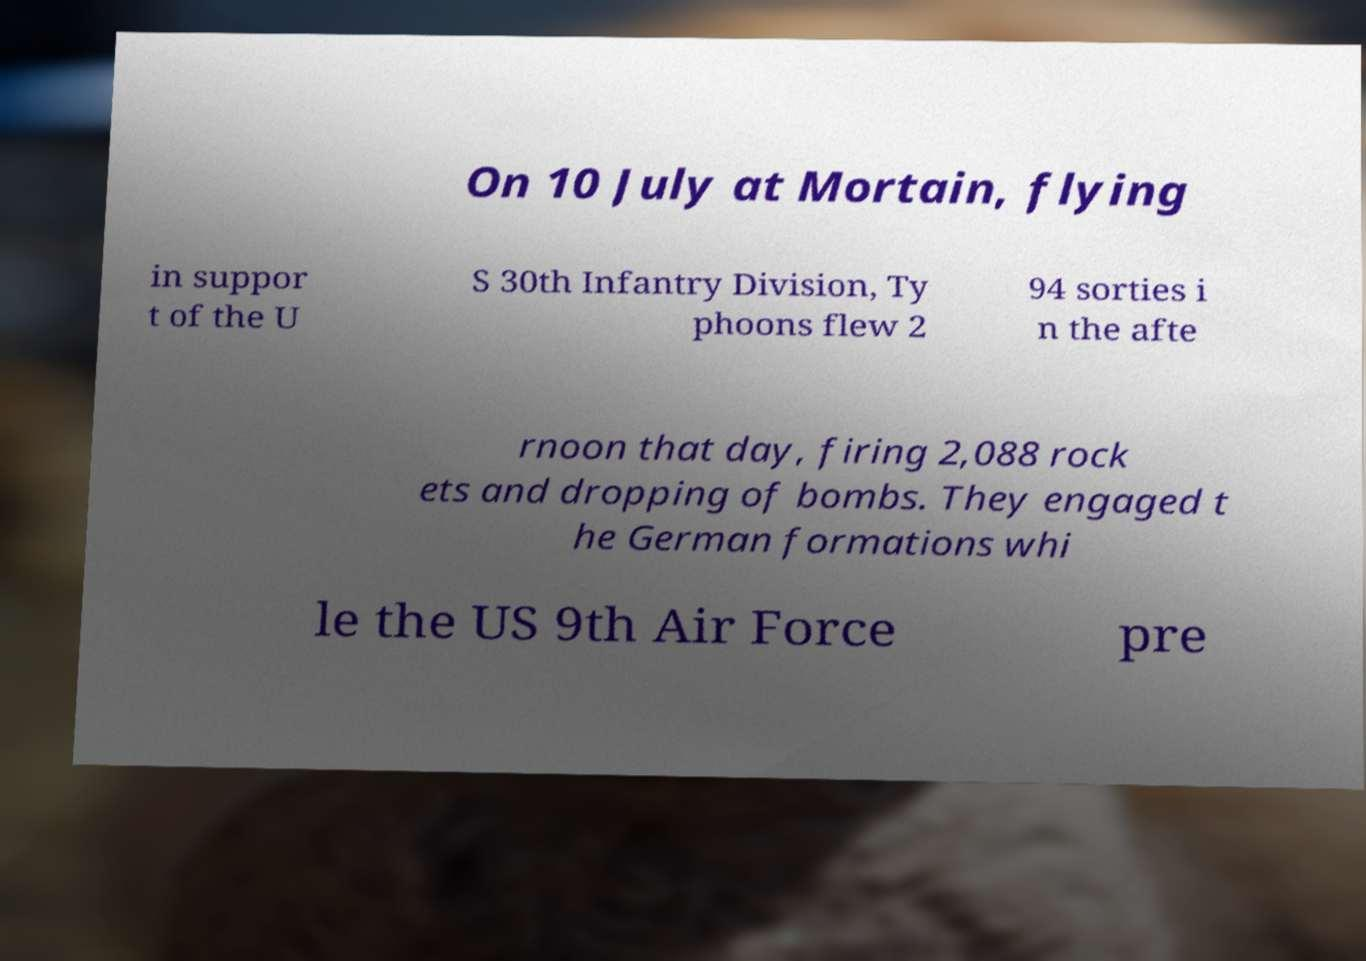Please read and relay the text visible in this image. What does it say? On 10 July at Mortain, flying in suppor t of the U S 30th Infantry Division, Ty phoons flew 2 94 sorties i n the afte rnoon that day, firing 2,088 rock ets and dropping of bombs. They engaged t he German formations whi le the US 9th Air Force pre 